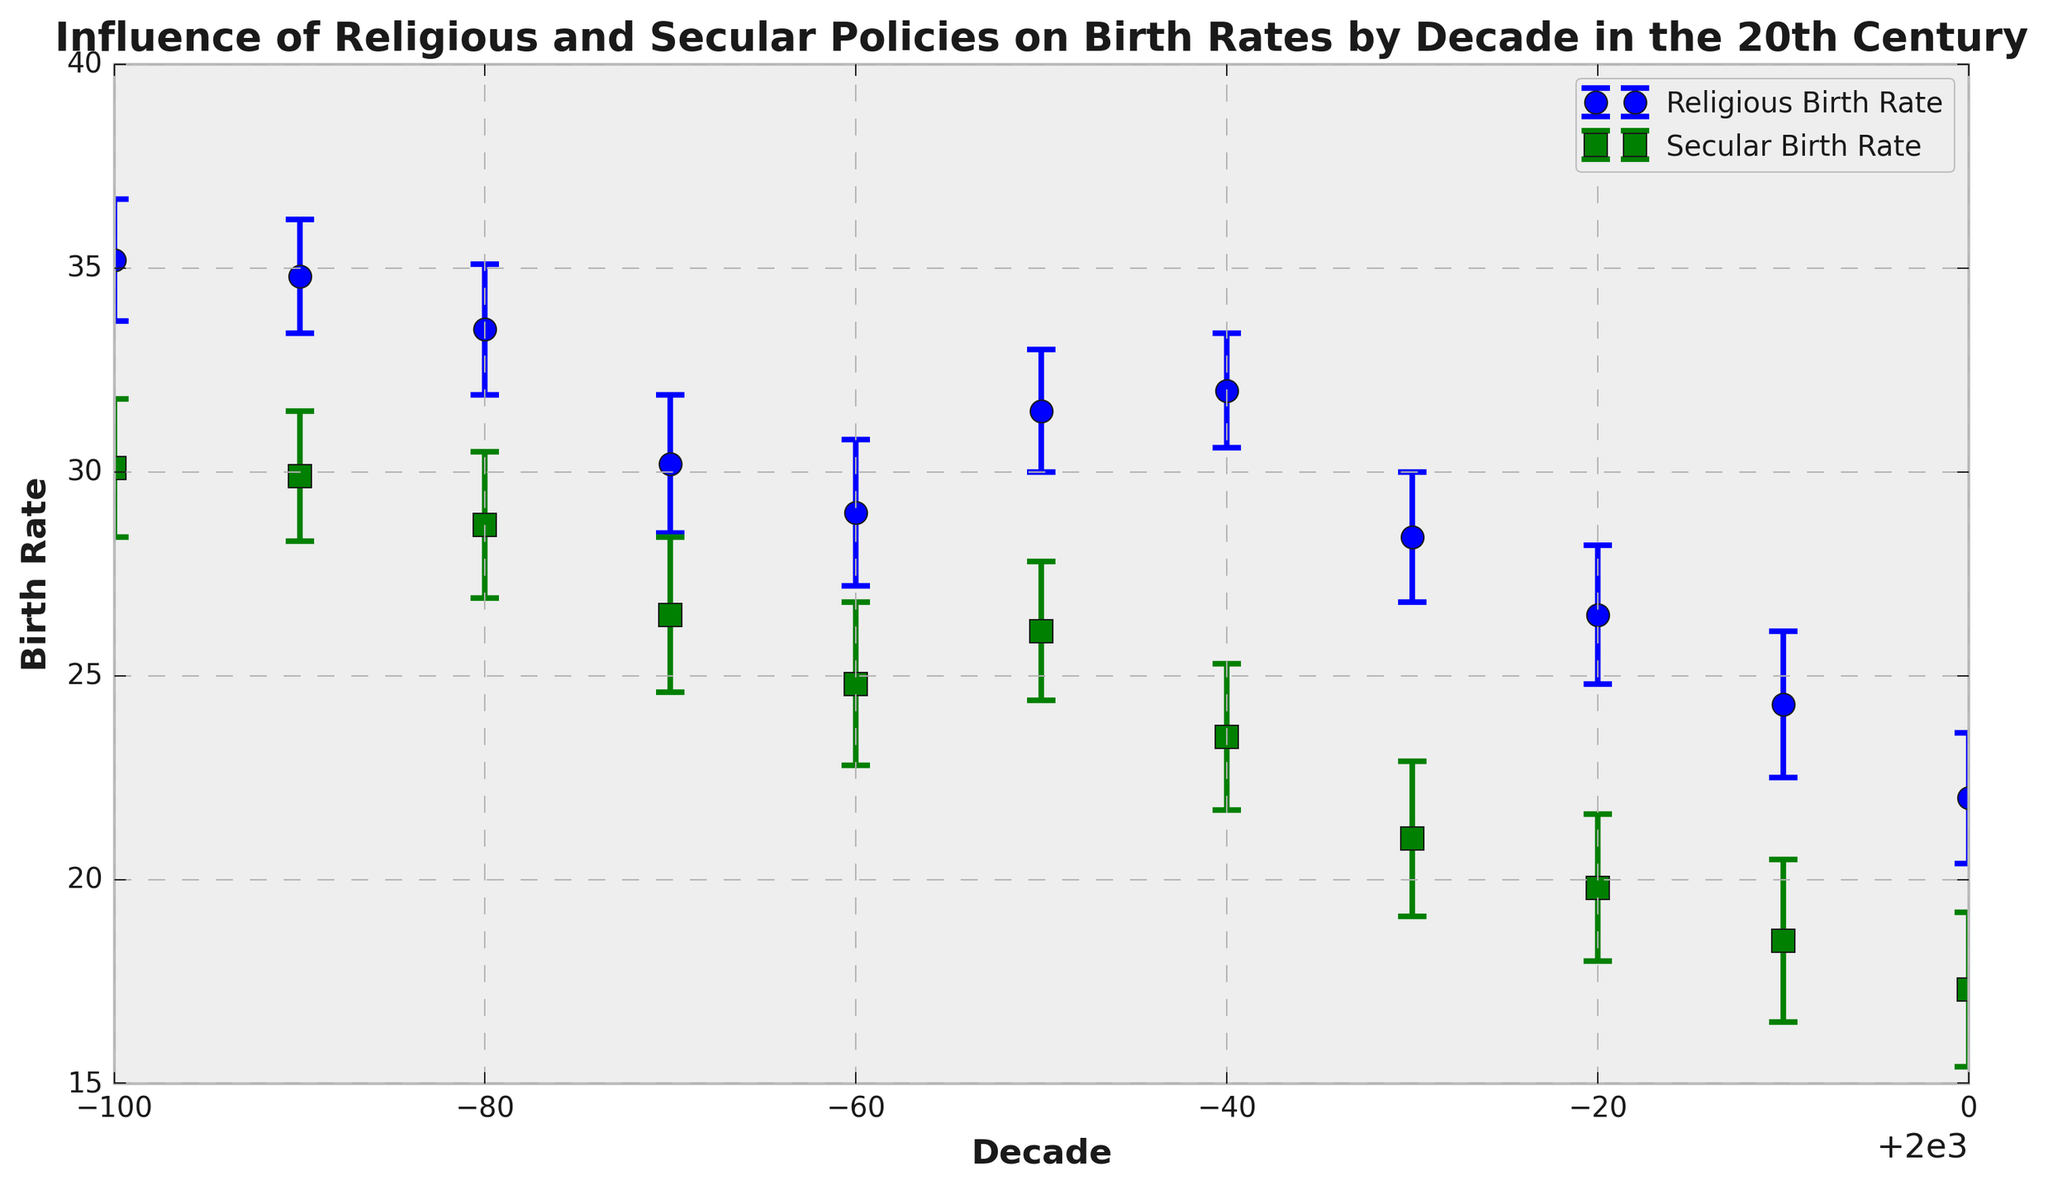What was the trend in the religious birth rate from 1900 to 2000? Observing the plot, the religious birth rate steadily declines from 1900 to 2000. It starts at approximately 35.2 in 1900 and drops to about 22.0 by 2000, showing a clear downtrend.
Answer: Steady decline During which decade was the difference between the religious and secular birth rates the greatest? To find this, observe the gap between the lines for each decade. The widest gap appears to be in 1900 where the religious birth rate is 35.2 and the secular is 30.1, leading to a difference of 5.1.
Answer: 1900 How does the overall trend of secular birth rates compare to that of religious birth rates throughout the century? While both secular and religious birth rates decline over the century, the secular birth rate consistently remains lower than the religious birth rate each decade and exhibits a steeper decline particularly from 1950 onwards.
Answer: Both decline, but secular rates are consistently lower What is the approximate average birth rate for religious policies across the whole century? Add up all the religious birth rates for each decade (35.2 + 34.8 + 33.5 + 30.2 + 29.0 + 31.5 + 32.0 + 28.4 + 26.5 + 24.3 + 22.0 = 327.4) and divide by the number of decades (11).
Answer: 29.8 In which decade did the secular birth rate see the largest decrease compared to its previous decade? Observe the drop between each consecutive decade in the secular line. The biggest decrease appears between 1950 (26.1) to 1960 (23.5), a decrease of 2.6.
Answer: 1950-1960 How would you describe the error bars for both religious and secular birth rates? The error bars, which represent the uncertainties, show a consistently narrow range with slight variations. For religious birth rates, errors are between 1.4 to 1.8, and for secular birth rates, errors are between 1.6 to 2.0.
Answer: Consistently narrow range During which decades were the birth rates the closest between religious and secular policies? Look for the decades where the markers for both birth rates are closest. This appears to occur in the 1930s and 1950s. In 1930, religious is about 30.2 and secular is about 26.5. In the 1950s, religious is 31.5 and secular is 26.1.
Answer: 1930s and 1950s How do the birth rates under secular policies compare from the start (1900) to the end of the century (2000)? In 1900, the secular birth rate starts at approximately 30.1 and drops to about 17.3 by 2000. This shows a significant decline over the century.
Answer: Significant decline Which policy showed more stability in birth rates over the century? By examining the plot, the religious birth rates show relatively smaller fluctuations around its trendline compared to the secular birth rates which show steeper drops and larger variations.
Answer: Religious policy In which decade did both policies exhibit their lowest birth rates? The lowest points for both lines should be observed in the plot, which occurs in 2000. Religious birth rate is around 22.0, and secular is around 17.3.
Answer: 2000 